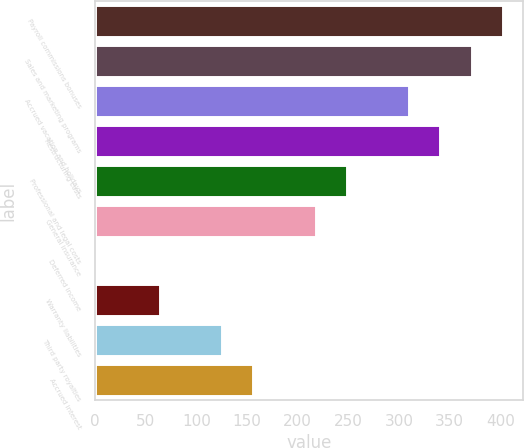<chart> <loc_0><loc_0><loc_500><loc_500><bar_chart><fcel>Payroll commissions bonuses<fcel>Sales and marketing programs<fcel>Accrued vacation and holidays<fcel>Restructuring costs<fcel>Professional and legal costs<fcel>General insurance<fcel>Deferred income<fcel>Warranty liabilities<fcel>Third party royalties<fcel>Accrued interest<nl><fcel>402.47<fcel>371.68<fcel>310.1<fcel>340.89<fcel>248.52<fcel>217.73<fcel>2.2<fcel>63.78<fcel>125.36<fcel>156.15<nl></chart> 